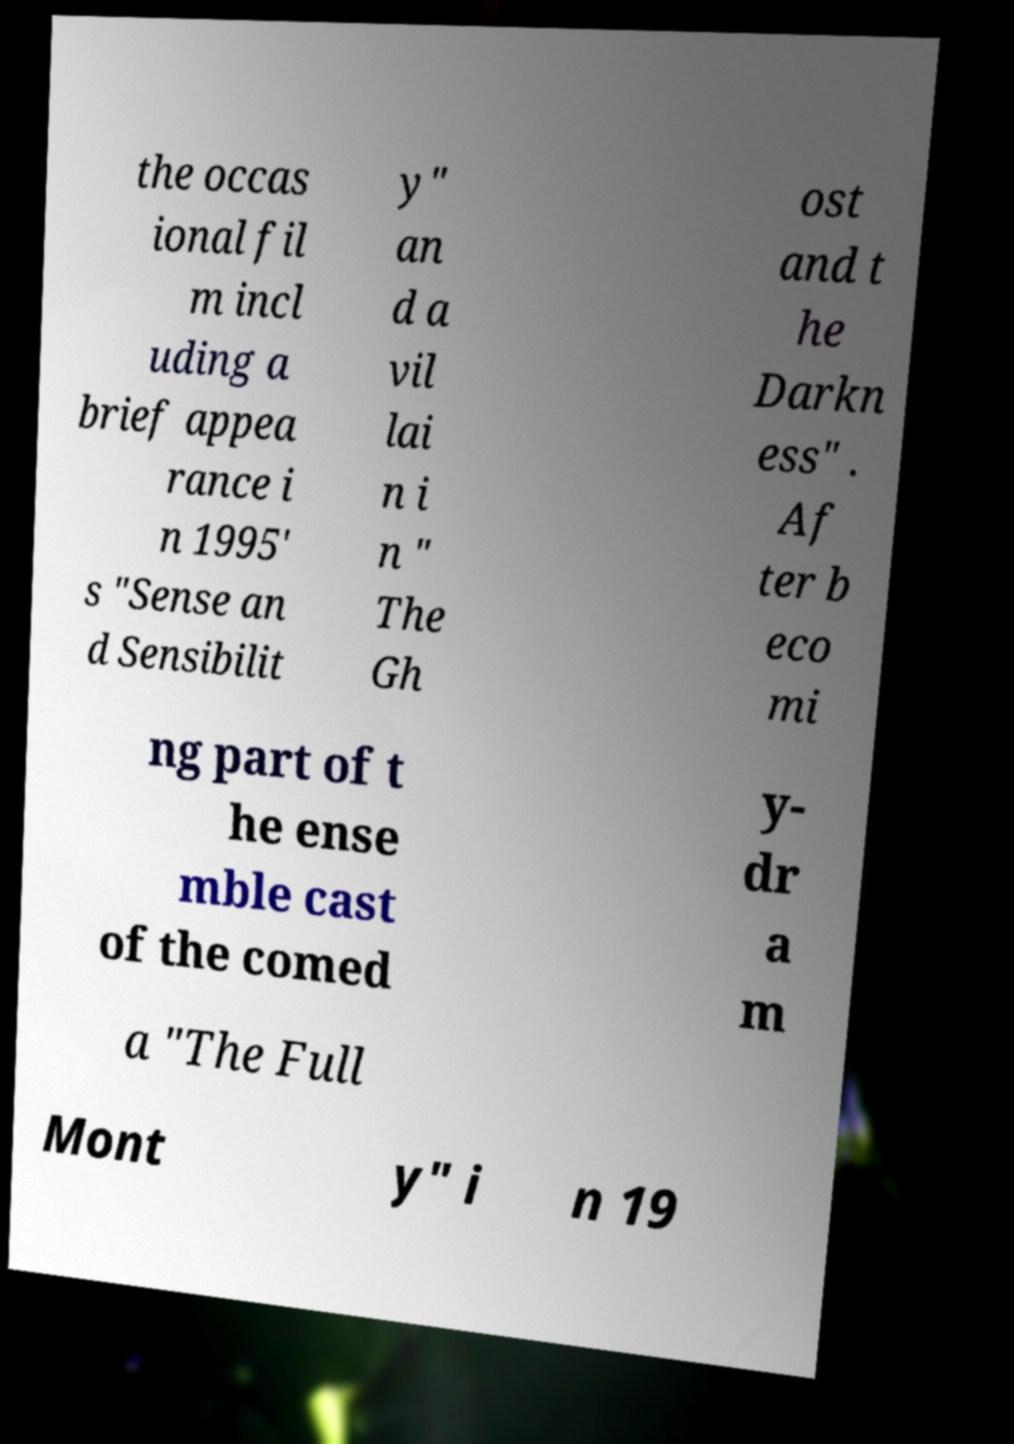I need the written content from this picture converted into text. Can you do that? the occas ional fil m incl uding a brief appea rance i n 1995' s "Sense an d Sensibilit y" an d a vil lai n i n " The Gh ost and t he Darkn ess" . Af ter b eco mi ng part of t he ense mble cast of the comed y- dr a m a "The Full Mont y" i n 19 